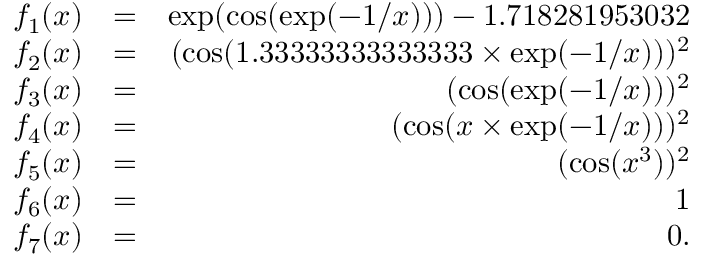Convert formula to latex. <formula><loc_0><loc_0><loc_500><loc_500>\begin{array} { r l r } { f _ { 1 } ( x ) } & { = } & { \exp ( \cos ( \exp ( - 1 / x ) ) ) - 1 . 7 1 8 2 8 1 9 5 3 0 3 2 } \\ { f _ { 2 } ( x ) } & { = } & { ( \cos ( 1 . 3 3 3 3 3 3 3 3 3 3 3 3 3 3 \times \exp ( - 1 / x ) ) ) ^ { 2 } } \\ { f _ { 3 } ( x ) } & { = } & { ( \cos ( \exp ( - 1 / x ) ) ) ^ { 2 } } \\ { f _ { 4 } ( x ) } & { = } & { ( \cos ( x \times \exp ( - 1 / x ) ) ) ^ { 2 } } \\ { f _ { 5 } ( x ) } & { = } & { ( \cos ( x ^ { 3 } ) ) ^ { 2 } } \\ { f _ { 6 } ( x ) } & { = } & { 1 } \\ { f _ { 7 } ( x ) } & { = } & { 0 . } \end{array}</formula> 